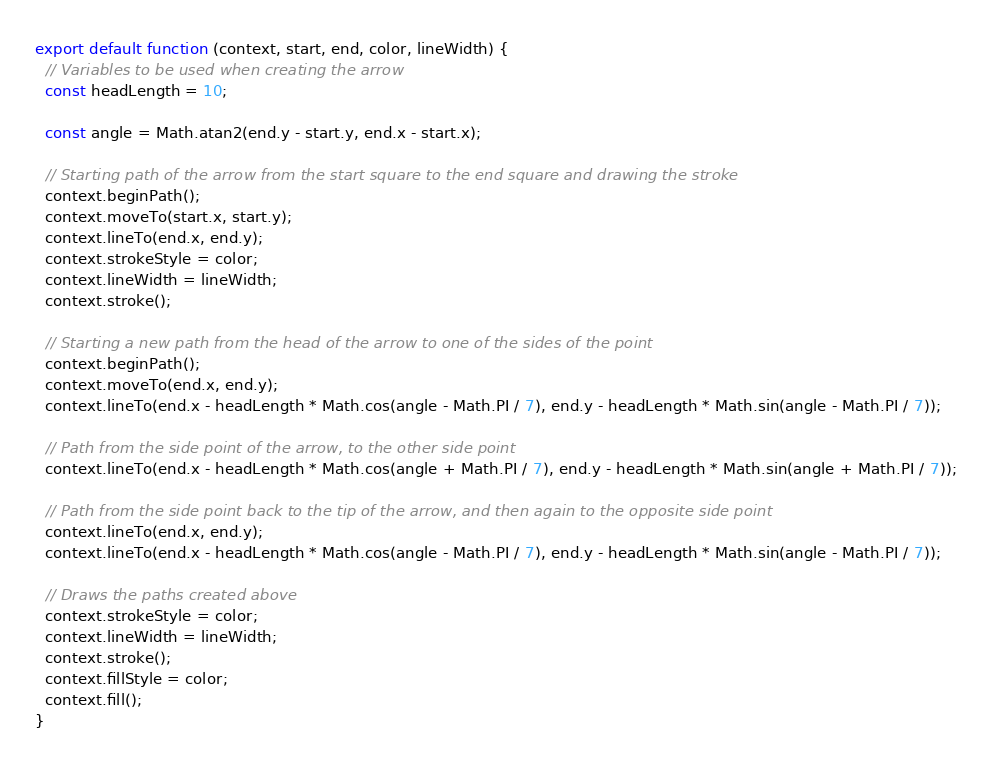<code> <loc_0><loc_0><loc_500><loc_500><_JavaScript_>export default function (context, start, end, color, lineWidth) {
  // Variables to be used when creating the arrow
  const headLength = 10;

  const angle = Math.atan2(end.y - start.y, end.x - start.x);

  // Starting path of the arrow from the start square to the end square and drawing the stroke
  context.beginPath();
  context.moveTo(start.x, start.y);
  context.lineTo(end.x, end.y);
  context.strokeStyle = color;
  context.lineWidth = lineWidth;
  context.stroke();

  // Starting a new path from the head of the arrow to one of the sides of the point
  context.beginPath();
  context.moveTo(end.x, end.y);
  context.lineTo(end.x - headLength * Math.cos(angle - Math.PI / 7), end.y - headLength * Math.sin(angle - Math.PI / 7));

  // Path from the side point of the arrow, to the other side point
  context.lineTo(end.x - headLength * Math.cos(angle + Math.PI / 7), end.y - headLength * Math.sin(angle + Math.PI / 7));

  // Path from the side point back to the tip of the arrow, and then again to the opposite side point
  context.lineTo(end.x, end.y);
  context.lineTo(end.x - headLength * Math.cos(angle - Math.PI / 7), end.y - headLength * Math.sin(angle - Math.PI / 7));

  // Draws the paths created above
  context.strokeStyle = color;
  context.lineWidth = lineWidth;
  context.stroke();
  context.fillStyle = color;
  context.fill();
}
</code> 